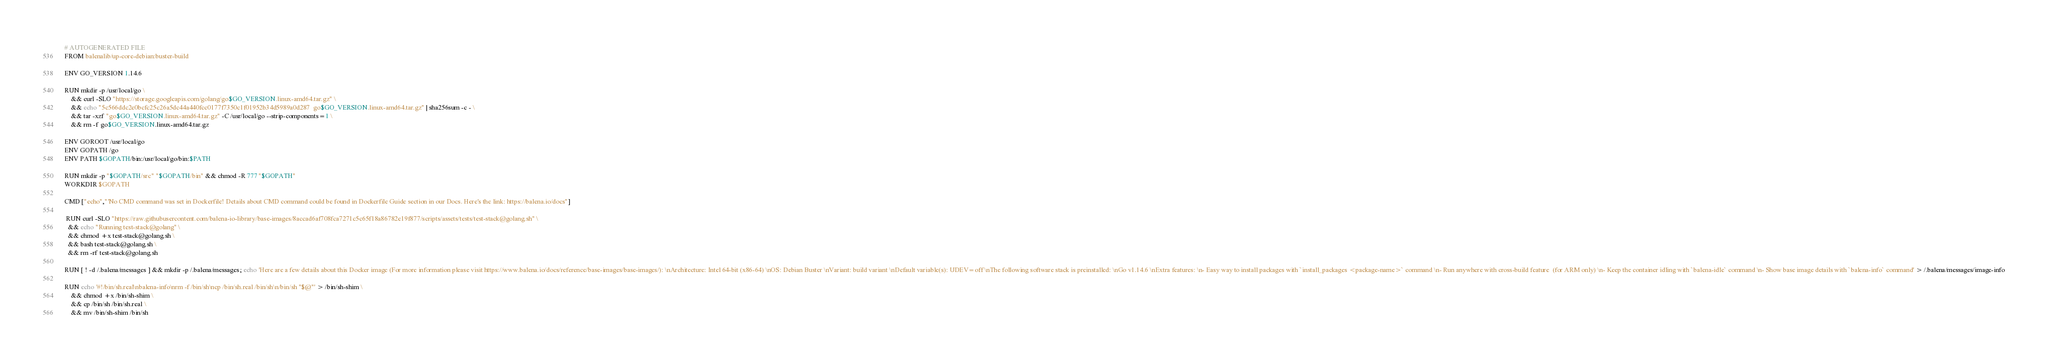<code> <loc_0><loc_0><loc_500><loc_500><_Dockerfile_># AUTOGENERATED FILE
FROM balenalib/up-core-debian:buster-build

ENV GO_VERSION 1.14.6

RUN mkdir -p /usr/local/go \
	&& curl -SLO "https://storage.googleapis.com/golang/go$GO_VERSION.linux-amd64.tar.gz" \
	&& echo "5c566ddc2e0bcfc25c26a5dc44a440fcc0177f7350c1f01952b34d5989a0d287  go$GO_VERSION.linux-amd64.tar.gz" | sha256sum -c - \
	&& tar -xzf "go$GO_VERSION.linux-amd64.tar.gz" -C /usr/local/go --strip-components=1 \
	&& rm -f go$GO_VERSION.linux-amd64.tar.gz

ENV GOROOT /usr/local/go
ENV GOPATH /go
ENV PATH $GOPATH/bin:/usr/local/go/bin:$PATH

RUN mkdir -p "$GOPATH/src" "$GOPATH/bin" && chmod -R 777 "$GOPATH"
WORKDIR $GOPATH

CMD ["echo","'No CMD command was set in Dockerfile! Details about CMD command could be found in Dockerfile Guide section in our Docs. Here's the link: https://balena.io/docs"]

 RUN curl -SLO "https://raw.githubusercontent.com/balena-io-library/base-images/8accad6af708fca7271c5c65f18a86782e19f877/scripts/assets/tests/test-stack@golang.sh" \
  && echo "Running test-stack@golang" \
  && chmod +x test-stack@golang.sh \
  && bash test-stack@golang.sh \
  && rm -rf test-stack@golang.sh 

RUN [ ! -d /.balena/messages ] && mkdir -p /.balena/messages; echo 'Here are a few details about this Docker image (For more information please visit https://www.balena.io/docs/reference/base-images/base-images/): \nArchitecture: Intel 64-bit (x86-64) \nOS: Debian Buster \nVariant: build variant \nDefault variable(s): UDEV=off \nThe following software stack is preinstalled: \nGo v1.14.6 \nExtra features: \n- Easy way to install packages with `install_packages <package-name>` command \n- Run anywhere with cross-build feature  (for ARM only) \n- Keep the container idling with `balena-idle` command \n- Show base image details with `balena-info` command' > /.balena/messages/image-info

RUN echo '#!/bin/sh.real\nbalena-info\nrm -f /bin/sh\ncp /bin/sh.real /bin/sh\n/bin/sh "$@"' > /bin/sh-shim \
	&& chmod +x /bin/sh-shim \
	&& cp /bin/sh /bin/sh.real \
	&& mv /bin/sh-shim /bin/sh</code> 